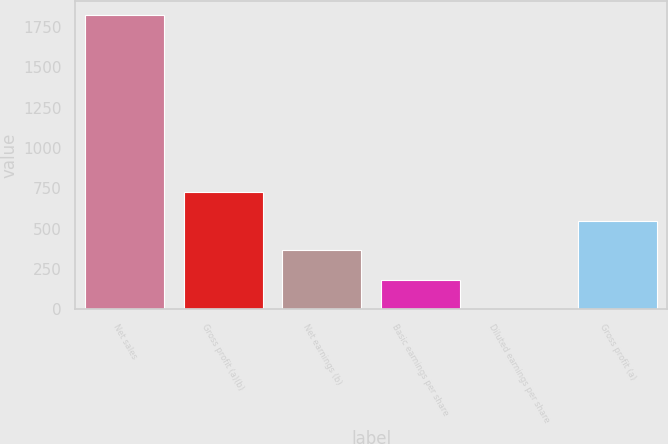Convert chart to OTSL. <chart><loc_0><loc_0><loc_500><loc_500><bar_chart><fcel>Net sales<fcel>Gross profit (a)(b)<fcel>Net earnings (b)<fcel>Basic earnings per share<fcel>Diluted earnings per share<fcel>Gross profit (a)<nl><fcel>1822.3<fcel>729.54<fcel>365.28<fcel>183.15<fcel>1.02<fcel>547.41<nl></chart> 